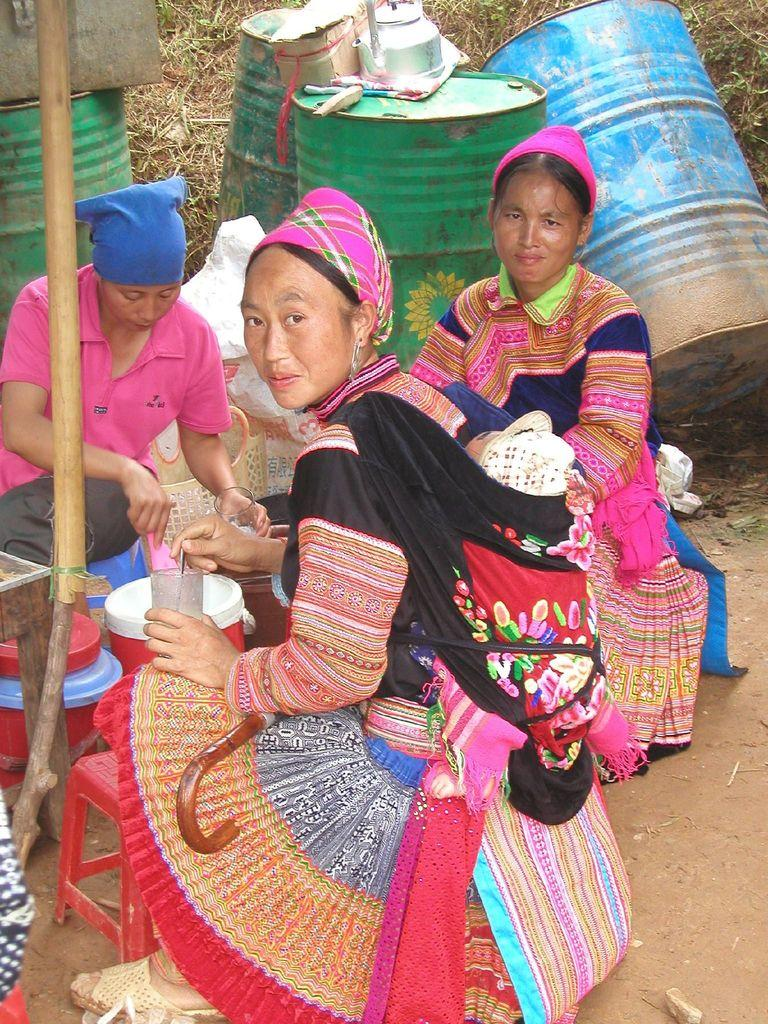What are the persons in the image doing? The persons in the image are sitting on chairs or stools. What can be seen in the background of the image? In the background of the image, there are bins, a kettle, a lawn or grass, and straws or similar objects. What type of queen is sitting on a throne in the image? There is no queen or throne present in the image; it features persons sitting on chairs or stools. What type of pest can be seen crawling on the persons in the image? There are no pests visible in the image; it only shows persons sitting on chairs or stools and items in the background. 